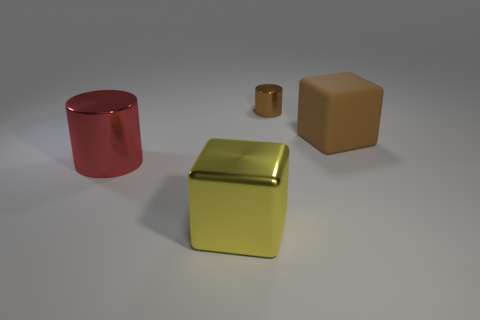Are there any other objects that have the same shape as the big red metal object?
Your answer should be compact. Yes. There is a large cube behind the metal block; is its color the same as the tiny thing?
Offer a terse response. Yes. There is a metallic cylinder that is in front of the tiny brown cylinder; is its size the same as the brown object that is left of the large rubber block?
Give a very brief answer. No. The red object that is the same material as the yellow object is what size?
Give a very brief answer. Large. What number of big objects are right of the small brown cylinder and left of the small brown shiny object?
Keep it short and to the point. 0. How many objects are either tiny gray metallic blocks or cubes right of the big yellow metallic cube?
Provide a short and direct response. 1. The small shiny thing that is the same color as the big rubber block is what shape?
Offer a very short reply. Cylinder. There is a large cube that is in front of the large cylinder; what color is it?
Make the answer very short. Yellow. How many objects are either large metal things on the right side of the big cylinder or small blue things?
Offer a very short reply. 1. What color is the metallic block that is the same size as the matte object?
Your response must be concise. Yellow. 